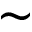Convert formula to latex. <formula><loc_0><loc_0><loc_500><loc_500>\sim</formula> 